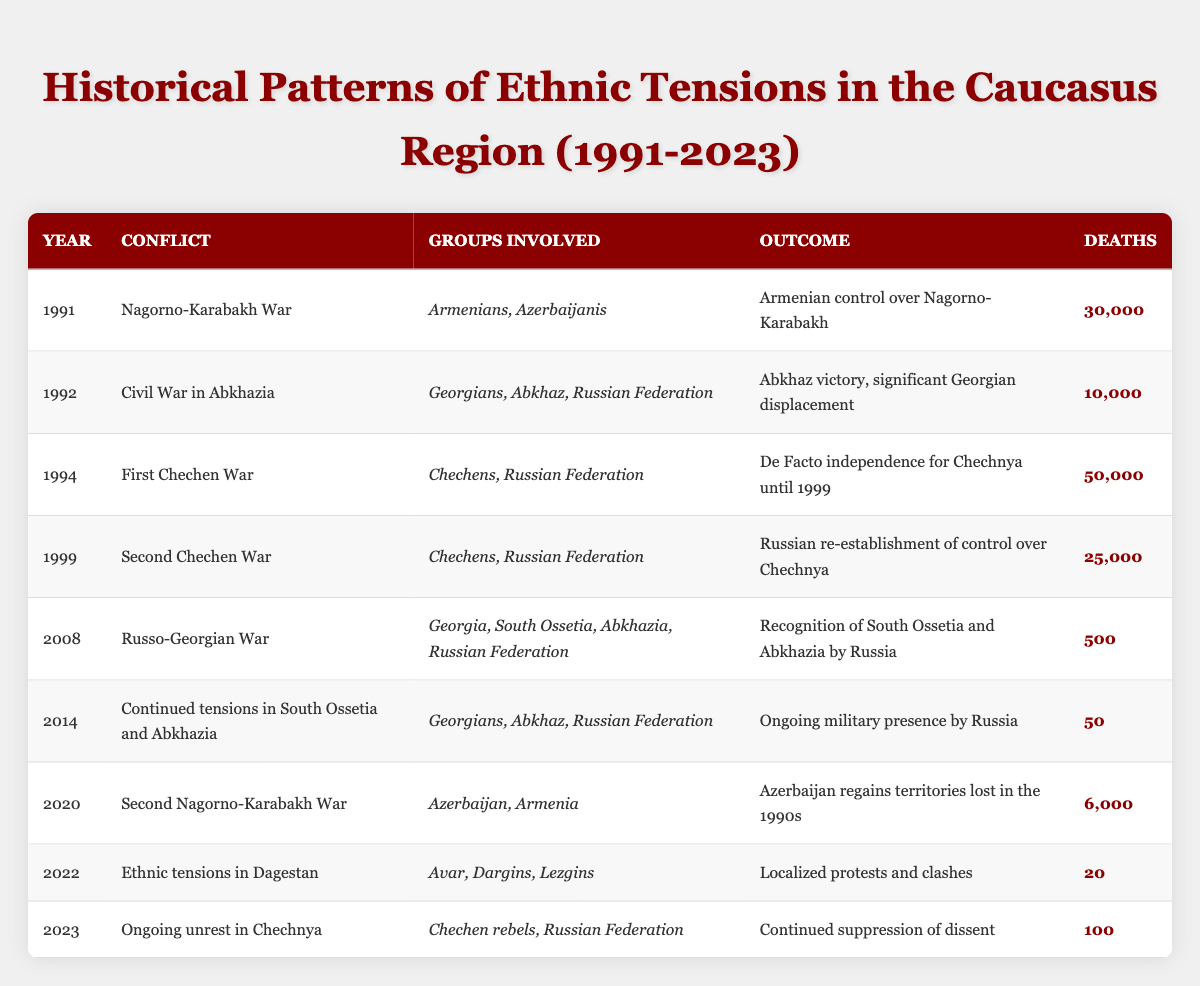What conflict involved Armenians and Azerbaijanis? According to the table, the conflict involving Armenians and Azerbaijanis is the Nagorno-Karabakh War, which occurred in 1991.
Answer: Nagorno-Karabakh War How many deaths were reported during the First Chechen War? From the table, the number of deaths reported during the First Chechen War in 1994 is 50,000.
Answer: 50,000 What was the outcome of the Russo-Georgian War? The table states that the outcome of the Russo-Georgian War in 2008 was the recognition of South Ossetia and Abkhazia by Russia.
Answer: Recognition of South Ossetia and Abkhazia by Russia What is the total number of deaths reported from the Second Chechen War and the ongoing unrest in Chechnya? To find the total, we add the deaths from the Second Chechen War in 1999 (25,000) and the ongoing unrest in Chechnya in 2023 (100), which gives us 25,000 + 100 = 25,100.
Answer: 25,100 Did the Civil War in Abkhazia result in a victory for the Abkhaz? The table indicates that the outcome of the Civil War in Abkhazia in 1992 was an Abkhaz victory, confirming that this statement is true.
Answer: Yes Which event had the least number of deaths reported in the table? By comparing the number of deaths from all events listed, the one with the least deaths is the ethnic tensions in Dagestan in 2022, which reported 20 deaths.
Answer: Ethnic tensions in Dagestan How many conflicts were reported between 1991 and 2008? The table contains four conflicts in the years specified: Nagorno-Karabakh War (1991), Civil War in Abkhazia (1992), First Chechen War (1994), and the Russo-Georgian War (2008). Therefore, there are four conflicts.
Answer: Four What was the main ethnic group involved in the 2022 events in Dagestan? According to the table, the main ethnic groups involved in the 2022 tensions in Dagestan were Avar, Dargins, and Lezgins, but only Avar can be considered as a reference ethnic group due to its first mention in the row.
Answer: Avar If we consider only conflicts with deaths greater than 10,000, how many events are listed? The table lists the following events with deaths greater than 10,000: Nagorno-Karabakh War (30,000), Civil War in Abkhazia (10,000), First Chechen War (50,000), and Second Chechen War (25,000), totaling four events. So the count is four.
Answer: Four 